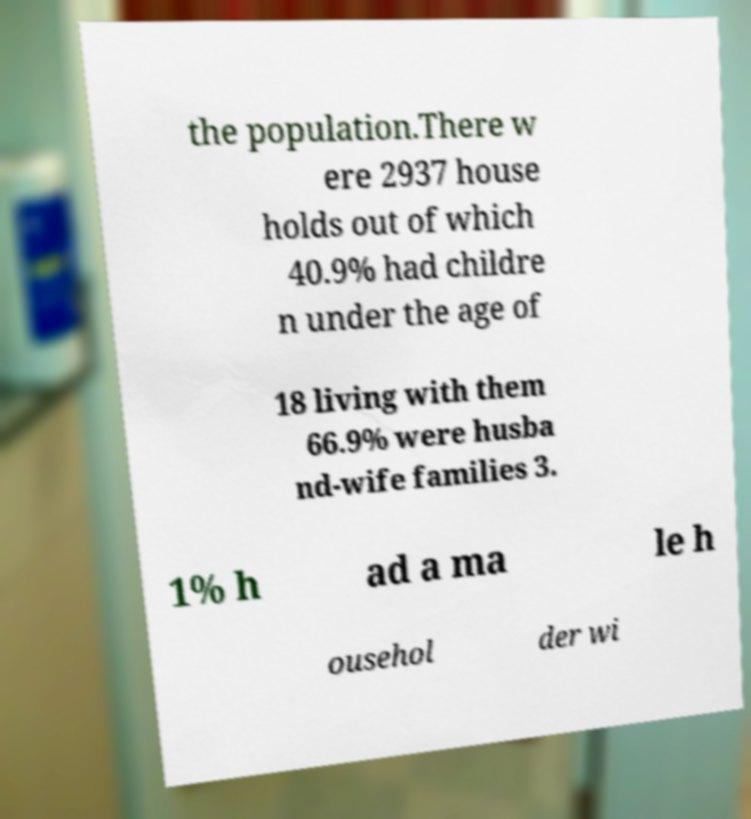What messages or text are displayed in this image? I need them in a readable, typed format. the population.There w ere 2937 house holds out of which 40.9% had childre n under the age of 18 living with them 66.9% were husba nd-wife families 3. 1% h ad a ma le h ousehol der wi 